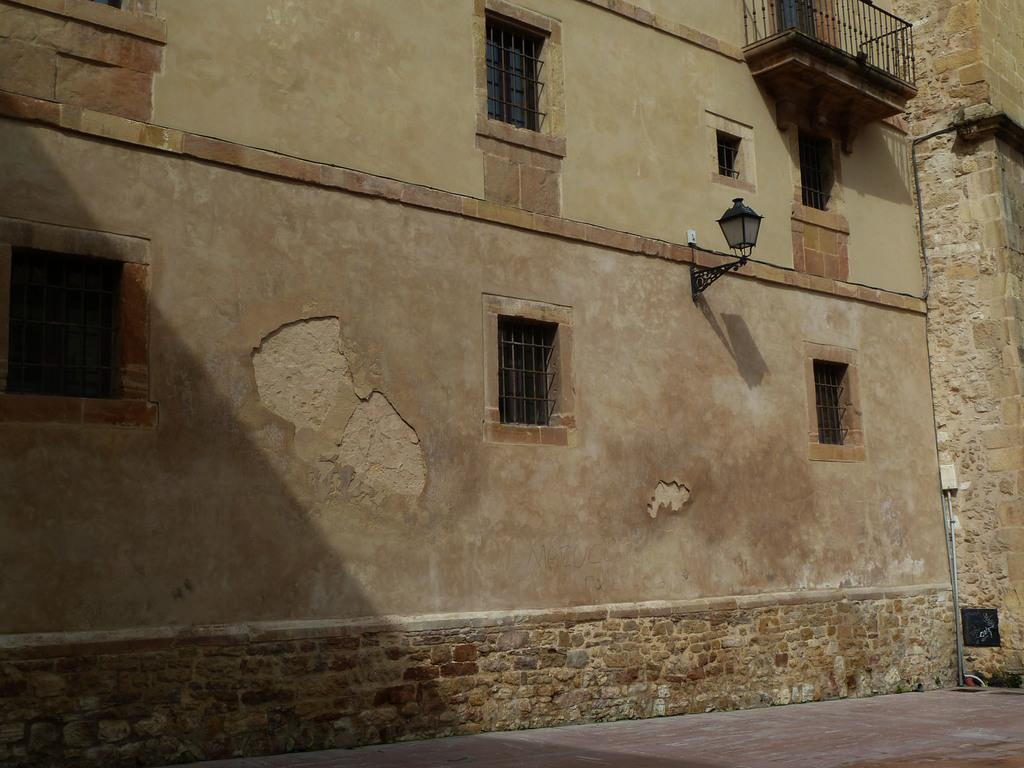What type of structure can be seen in the image? There is a wall in the image. What feature allows light to enter the space in the image? There are windows in the image. Can you describe the lighting conditions in the image? There is light visible in the image. Where is the mom standing in the image? There is no mom present in the image. What type of gardening tool can be seen in the image? There is no gardening tool, such as a spade, present in the image. 